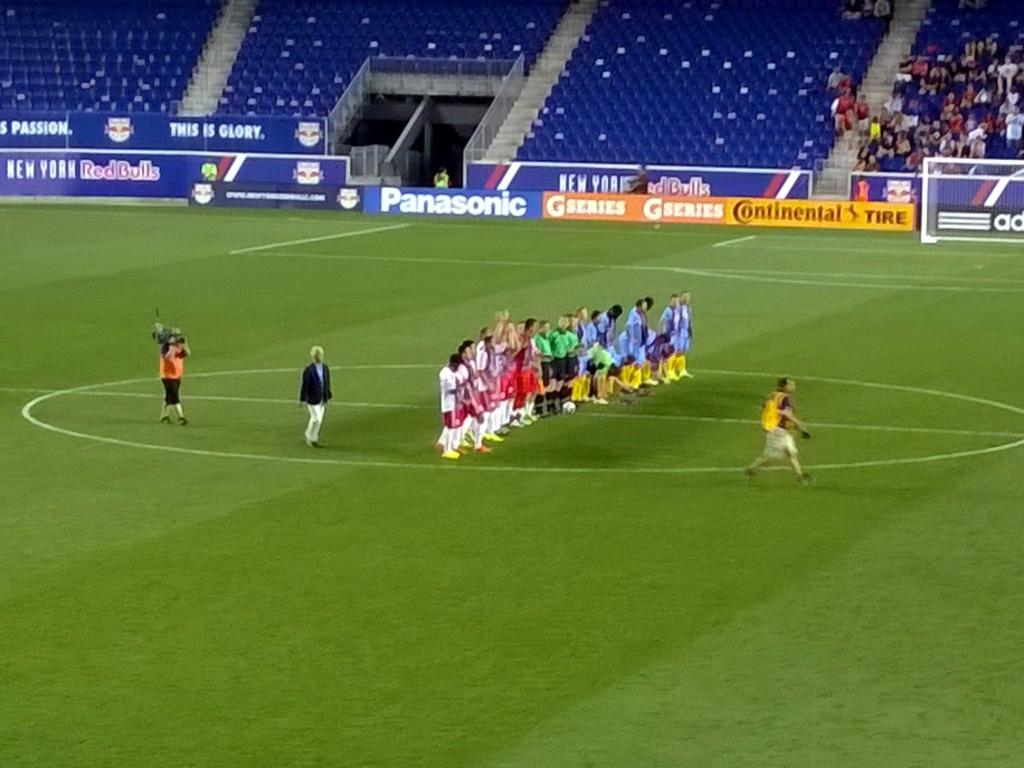<image>
Give a short and clear explanation of the subsequent image. the game is sponsored by Panasonic and Continental Tire 